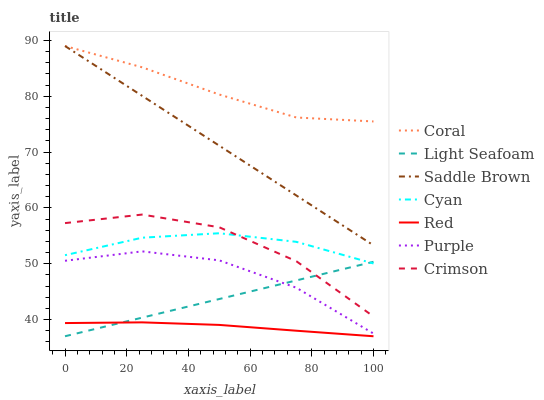Does Crimson have the minimum area under the curve?
Answer yes or no. No. Does Crimson have the maximum area under the curve?
Answer yes or no. No. Is Coral the smoothest?
Answer yes or no. No. Is Coral the roughest?
Answer yes or no. No. Does Crimson have the lowest value?
Answer yes or no. No. Does Crimson have the highest value?
Answer yes or no. No. Is Purple less than Cyan?
Answer yes or no. Yes. Is Cyan greater than Red?
Answer yes or no. Yes. Does Purple intersect Cyan?
Answer yes or no. No. 